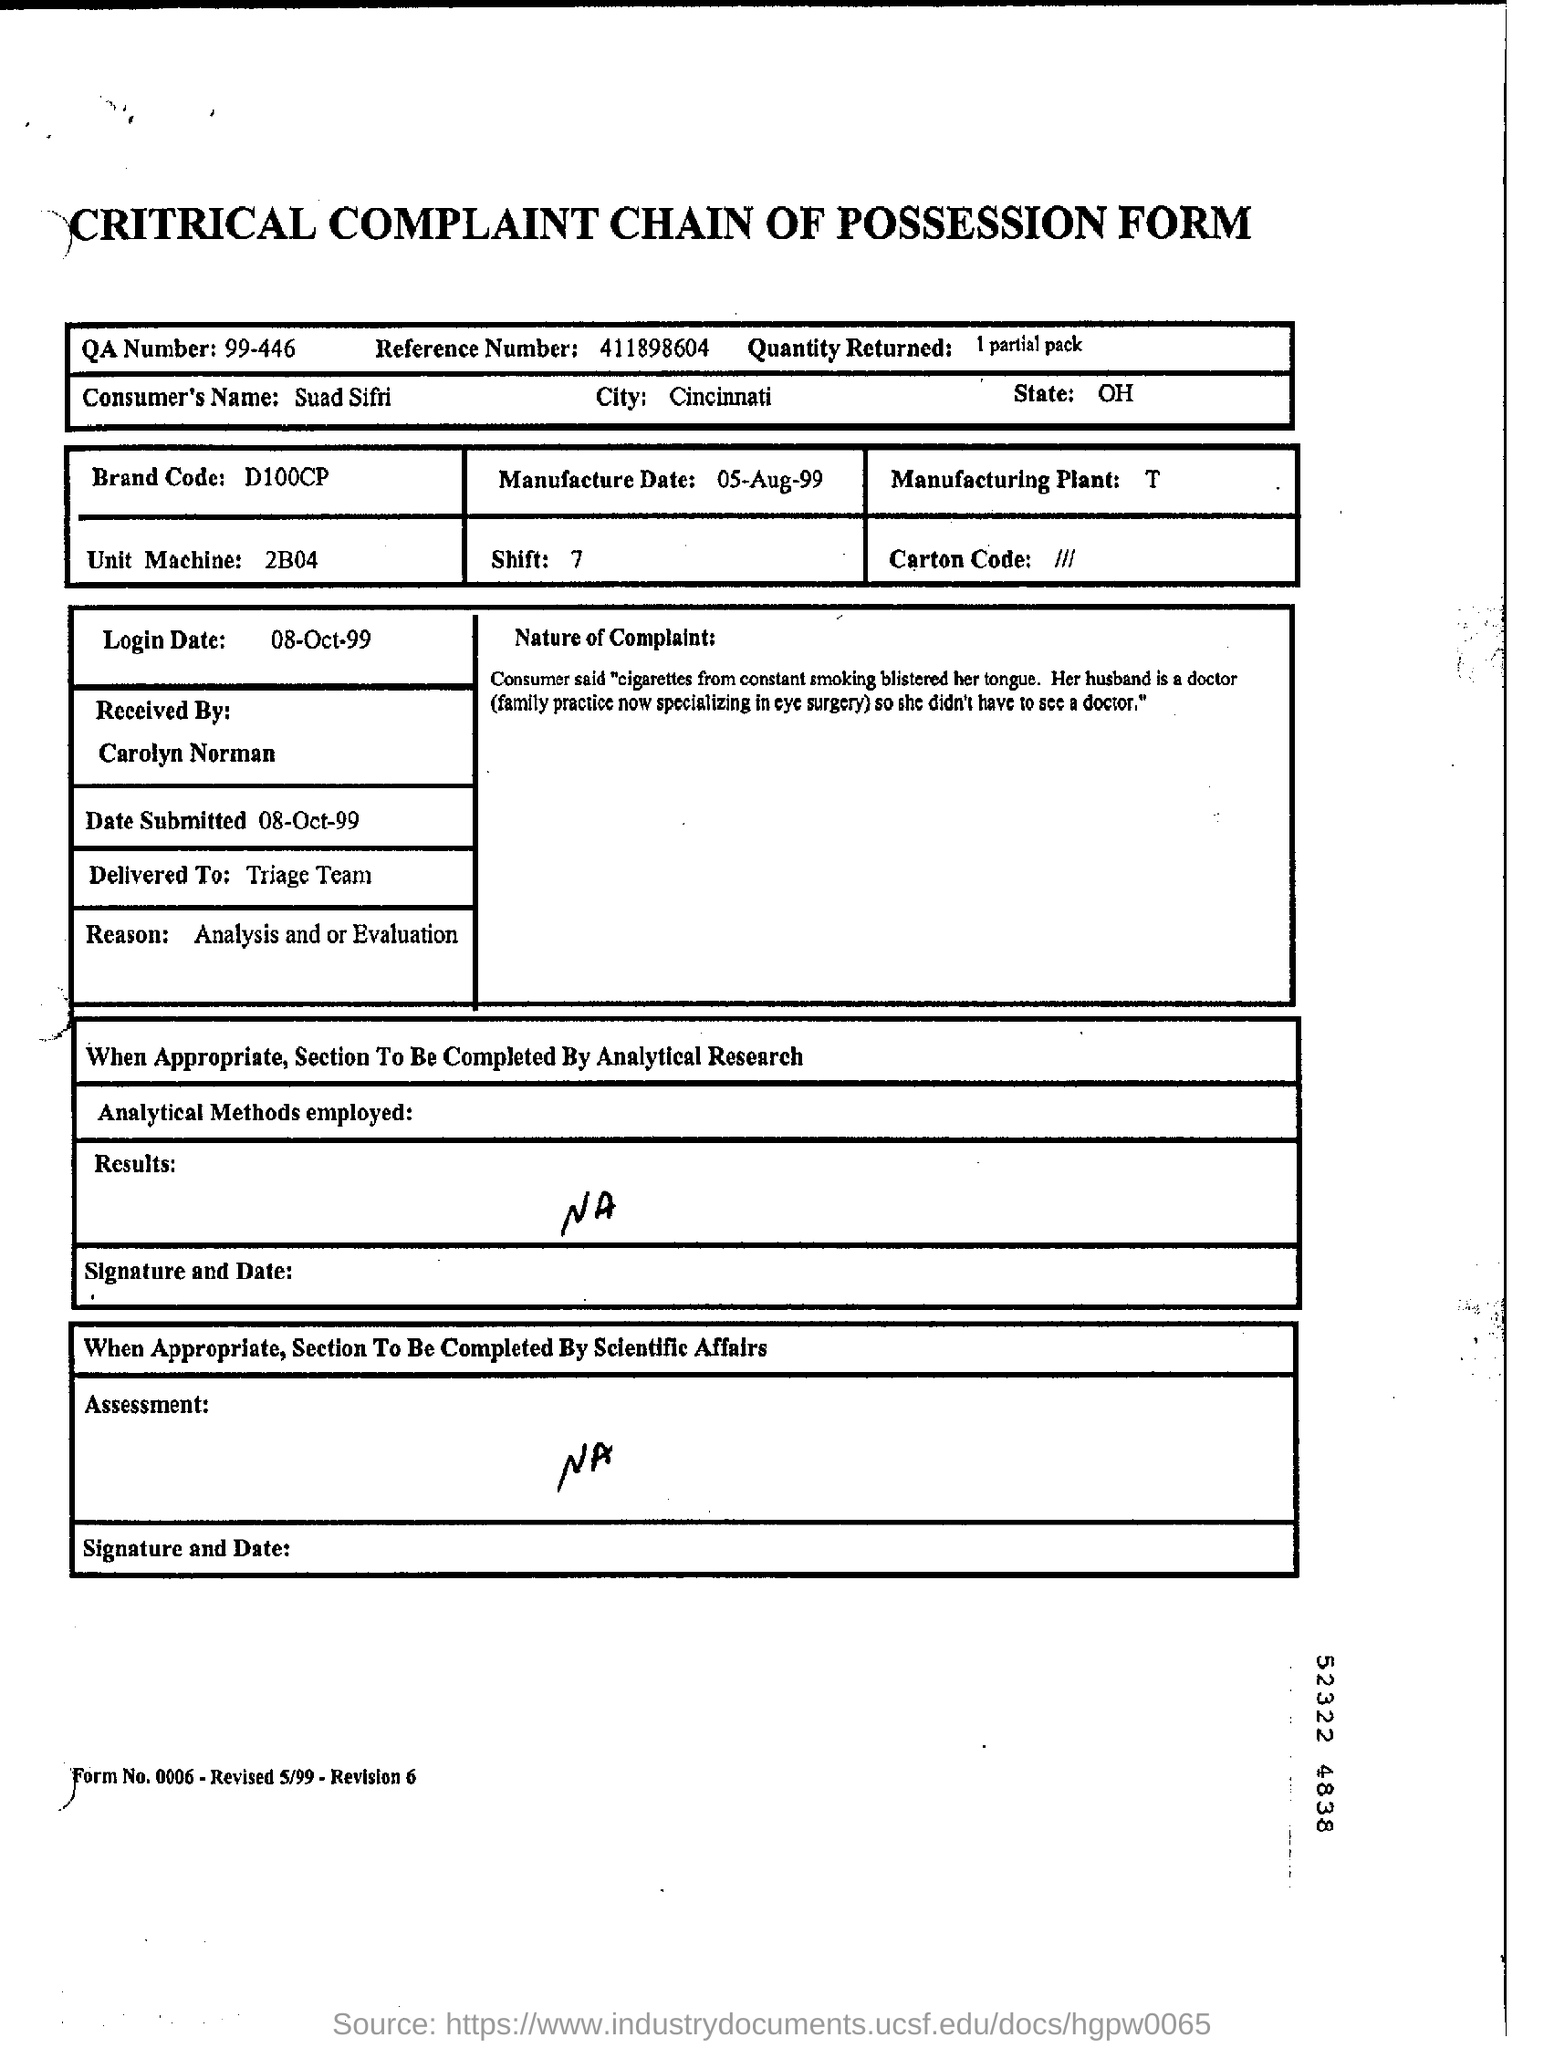Identify some key points in this picture. What is mentioned as reason? Analysis and/or evaluation. The QA number is a unique identifier assigned to a specific version of a software, as represented by the string '99-446'. This identifier serves as a reference point for tracking and managing software releases within a development lifecycle. The term 'brand code' refers to a unique identifier, typically in the format D100CP, which is assigned to a specific brand or product for tracking and identification purposes. 